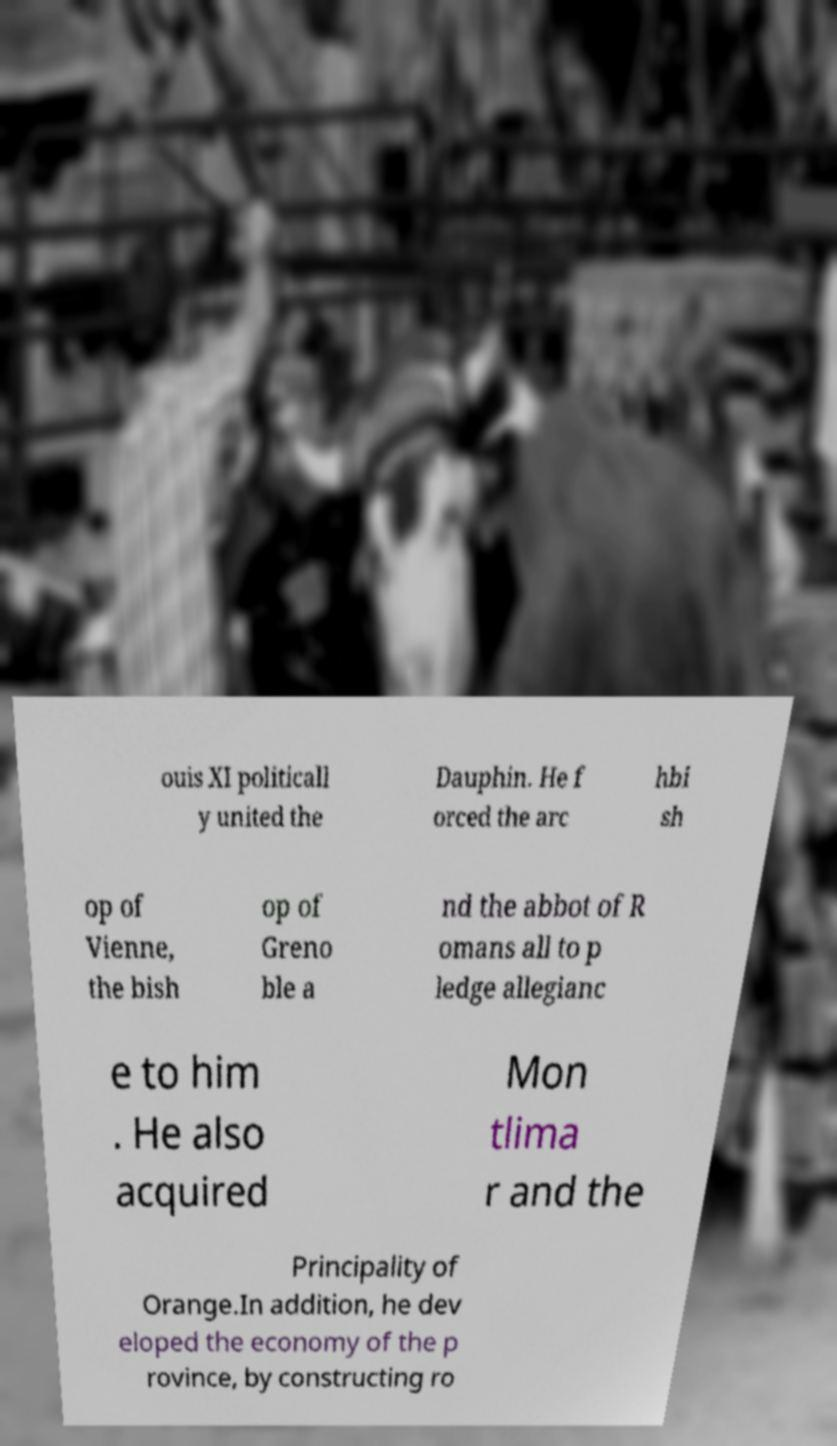What messages or text are displayed in this image? I need them in a readable, typed format. ouis XI politicall y united the Dauphin. He f orced the arc hbi sh op of Vienne, the bish op of Greno ble a nd the abbot of R omans all to p ledge allegianc e to him . He also acquired Mon tlima r and the Principality of Orange.In addition, he dev eloped the economy of the p rovince, by constructing ro 